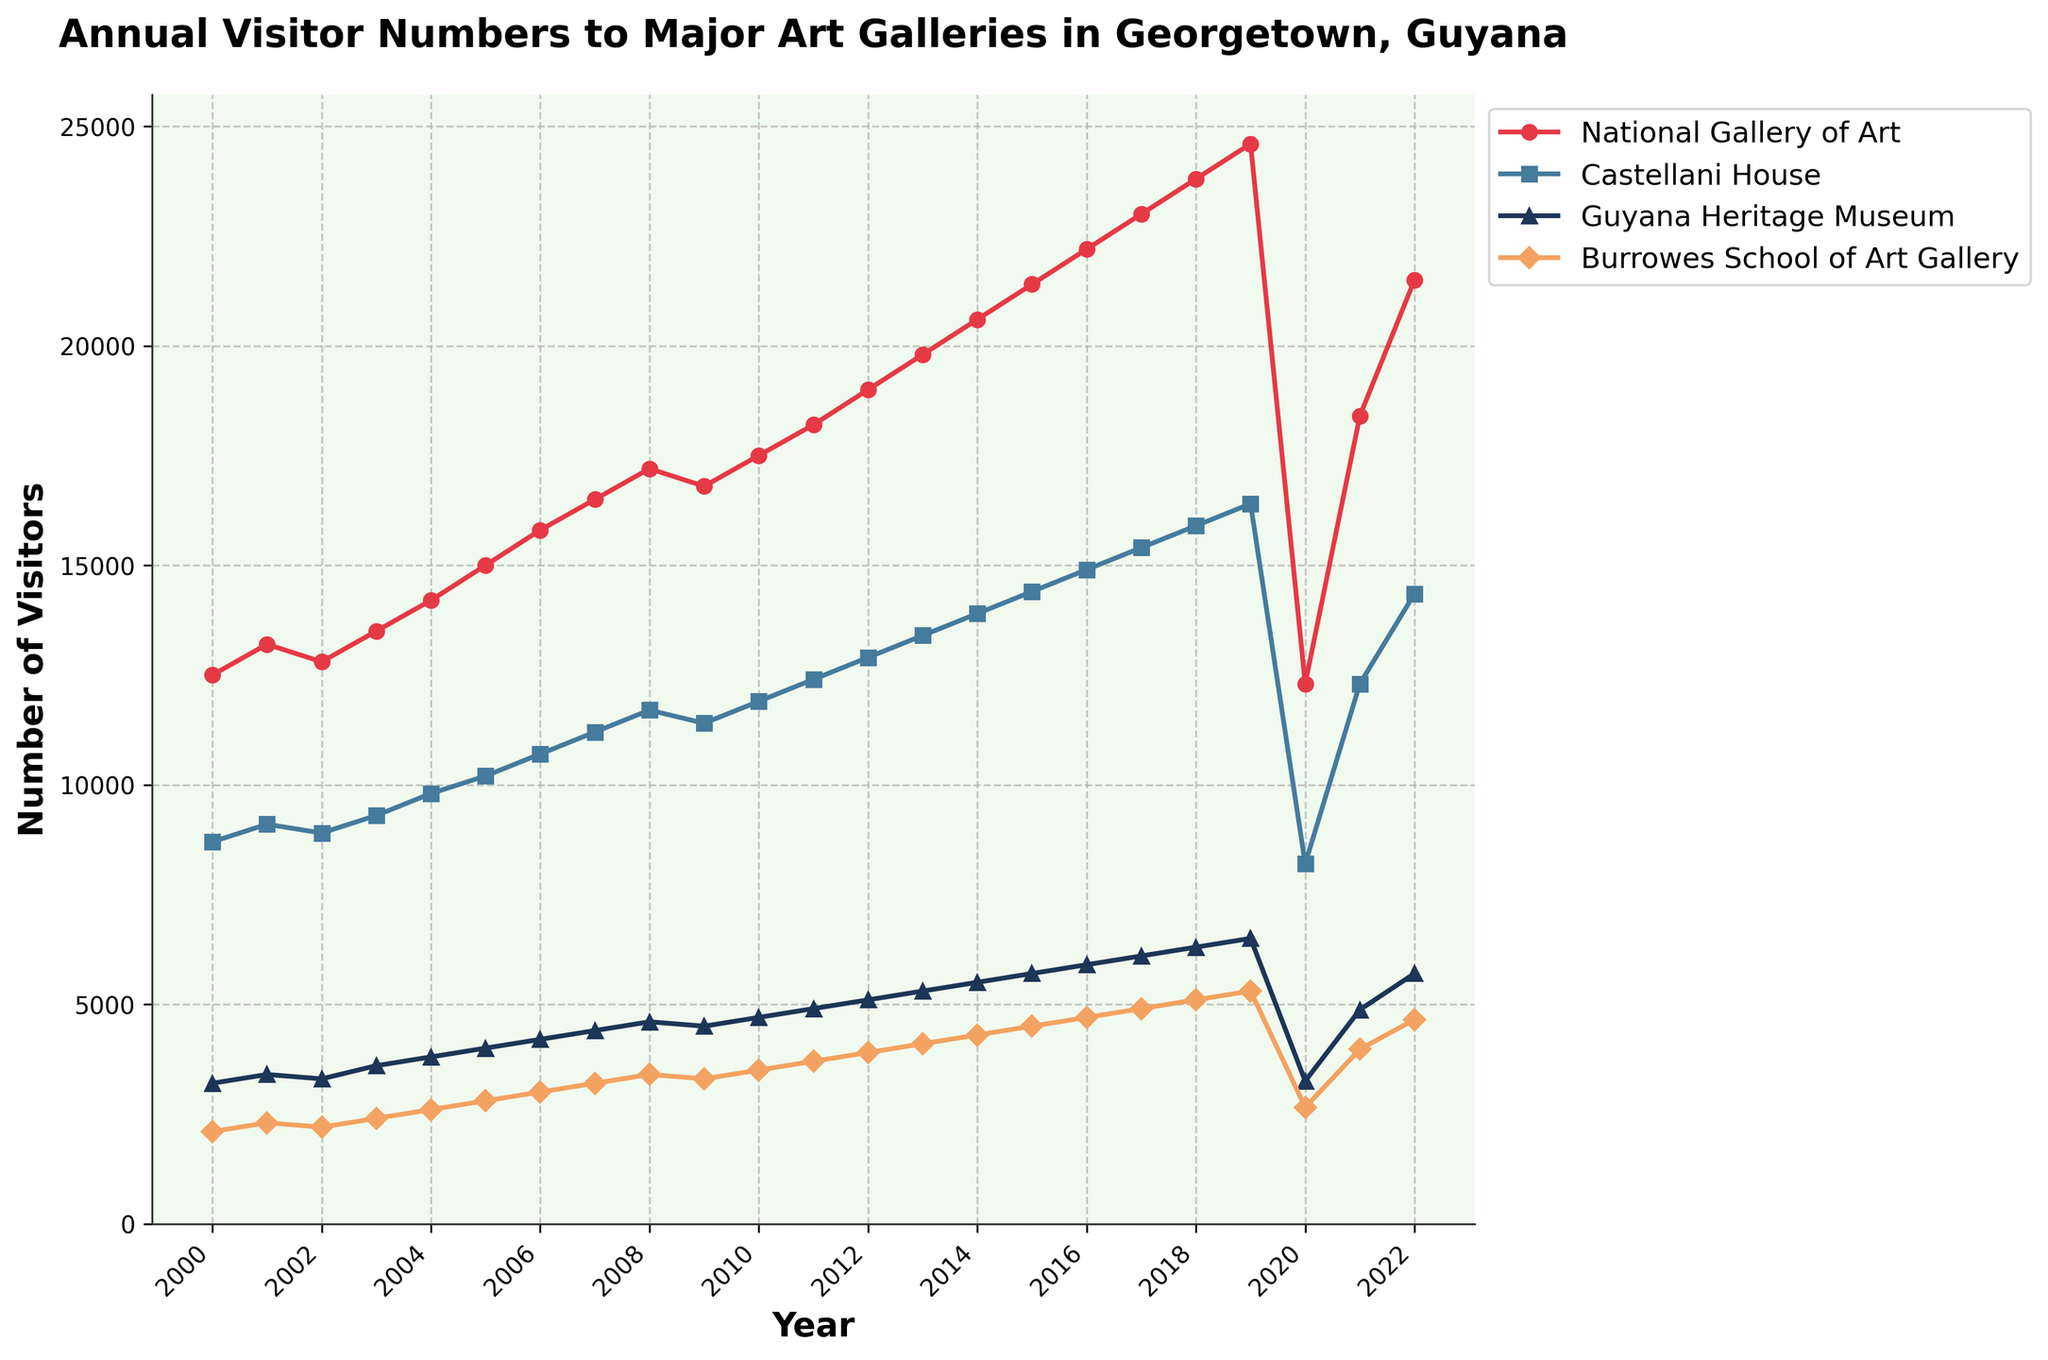what trend can be observed in visitor numbers to the National Gallery of Art from 2000 to 2022? The visitor numbers to the National Gallery of Art generally increased from 2000 to 2019, then sharply declined in 2020 before rebounding again in 2021 and 2022.
Answer: Increasing trend with a dip in 2020 which year saw the highest number of visitors for the Guyana Heritage Museum? By examining the line representing the Guyana Heritage Museum, the peak visitor count is in 2019.
Answer: 2019 how did the visitor numbers to Castellani House change in 2020 compared to 2019? The visitor numbers for Castellani House saw a significant drop from approximately 16,400 in 2019 to 8,200 in 2020.
Answer: Decreased what are the two art galleries with the most similar visitor numbers in 2022? By comparing the heights of the lines in 2022, Castellani House and Borroughes School of Art Gallery have the most similar visitor numbers, both ranging around 14,350 and 4,650 respectively.
Answer: Castellani House and Burrowes School of Art Gallery which art gallery experienced the smallest change in visitor numbers between 2000 and 2022? From the start and end points of each line, the Burrowes School of Art Gallery shows the smallest increase from 2,100 in 2000 to 4,650 in 2022.
Answer: Burrowes School of Art Gallery in which year did the National Gallery of Art see a visitor count close to 20,000? The line representing the National Gallery of Art touches approximately 20,000 visitors in 2014.
Answer: 2014 compare the total number of visitors in 2022 for all four art galleries combined to the total in 2000. First, sum the values in 2022: 21,500 (National Gallery of Art) + 14,350 (Castellani House) + 5,700 (Guyana Heritage Museum) + 4,650 (Burrowes School of Art Gallery) = 46,200. Then, sum the values in 2000: 12,500 (National Gallery of Art) + 8,700 (Castellani House) + 3,200 (Guyana Heritage Museum) + 2,100 (Burrowes School of Art Gallery) = 26,500. Comparing the two totals: 46,200 (2022) is greater than 26,500 (2000) by 19,700.
Answer: Increased by 19,700 which set of years shows a steady increase in visitor numbers to the Burrowes School of Art Gallery? From the plot, Burrowes School of Art Gallery shows a steady increase in visitor numbers between 2000 and 2019.
Answer: 2000 to 2019 during which years did the visitor numbers to the Guyana Heritage Museum stay roughly constant before showing an increasing trend? Visitor numbers to the Guyana Heritage Museum remained relatively stable around 3,200 to 3,600 from 2000 to 2003 before they started increasing.
Answer: 2000 to 2003 